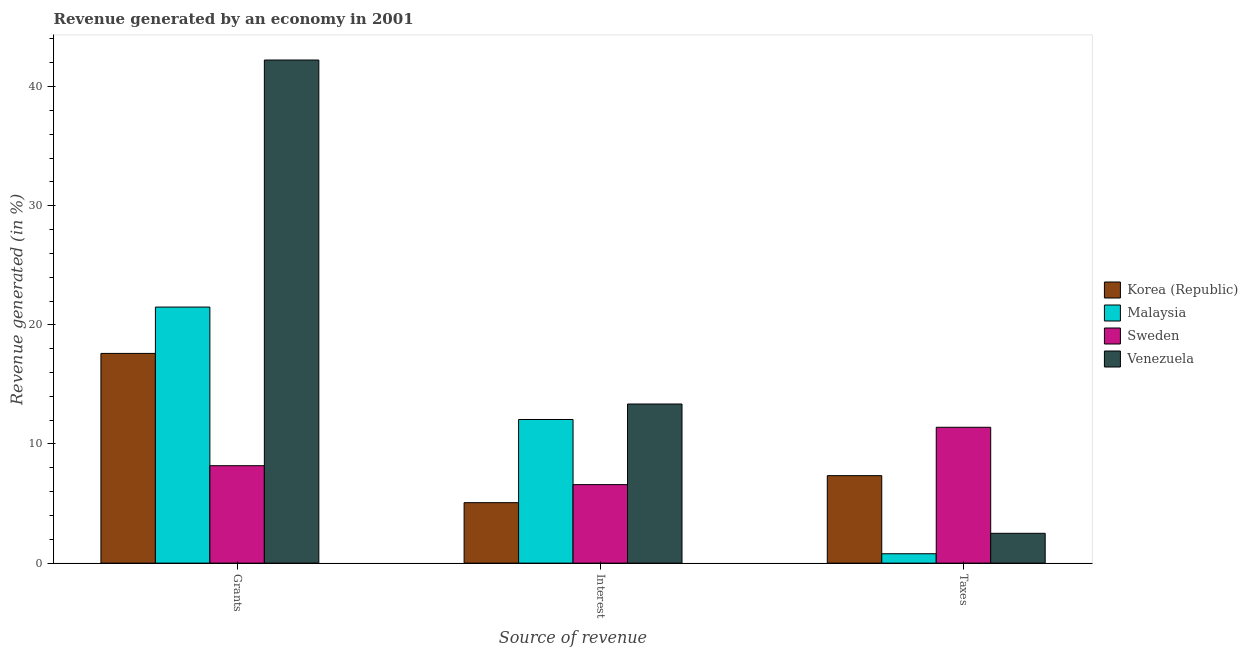Are the number of bars on each tick of the X-axis equal?
Offer a very short reply. Yes. How many bars are there on the 3rd tick from the right?
Give a very brief answer. 4. What is the label of the 1st group of bars from the left?
Provide a short and direct response. Grants. What is the percentage of revenue generated by taxes in Korea (Republic)?
Ensure brevity in your answer.  7.34. Across all countries, what is the maximum percentage of revenue generated by interest?
Provide a short and direct response. 13.35. Across all countries, what is the minimum percentage of revenue generated by interest?
Make the answer very short. 5.07. In which country was the percentage of revenue generated by interest maximum?
Provide a succinct answer. Venezuela. In which country was the percentage of revenue generated by grants minimum?
Offer a very short reply. Sweden. What is the total percentage of revenue generated by grants in the graph?
Give a very brief answer. 89.49. What is the difference between the percentage of revenue generated by interest in Venezuela and that in Malaysia?
Provide a short and direct response. 1.3. What is the difference between the percentage of revenue generated by grants in Korea (Republic) and the percentage of revenue generated by interest in Malaysia?
Provide a short and direct response. 5.55. What is the average percentage of revenue generated by grants per country?
Offer a terse response. 22.37. What is the difference between the percentage of revenue generated by interest and percentage of revenue generated by taxes in Venezuela?
Offer a very short reply. 10.85. What is the ratio of the percentage of revenue generated by taxes in Malaysia to that in Korea (Republic)?
Provide a succinct answer. 0.11. Is the percentage of revenue generated by interest in Malaysia less than that in Sweden?
Your answer should be very brief. No. What is the difference between the highest and the second highest percentage of revenue generated by grants?
Give a very brief answer. 20.73. What is the difference between the highest and the lowest percentage of revenue generated by taxes?
Your answer should be very brief. 10.62. What does the 2nd bar from the right in Taxes represents?
Offer a very short reply. Sweden. Are all the bars in the graph horizontal?
Your response must be concise. No. How many countries are there in the graph?
Give a very brief answer. 4. Are the values on the major ticks of Y-axis written in scientific E-notation?
Ensure brevity in your answer.  No. Does the graph contain any zero values?
Keep it short and to the point. No. Does the graph contain grids?
Provide a short and direct response. No. How many legend labels are there?
Provide a succinct answer. 4. What is the title of the graph?
Offer a terse response. Revenue generated by an economy in 2001. What is the label or title of the X-axis?
Provide a short and direct response. Source of revenue. What is the label or title of the Y-axis?
Offer a terse response. Revenue generated (in %). What is the Revenue generated (in %) of Korea (Republic) in Grants?
Keep it short and to the point. 17.6. What is the Revenue generated (in %) in Malaysia in Grants?
Ensure brevity in your answer.  21.49. What is the Revenue generated (in %) in Sweden in Grants?
Your response must be concise. 8.18. What is the Revenue generated (in %) in Venezuela in Grants?
Your response must be concise. 42.23. What is the Revenue generated (in %) of Korea (Republic) in Interest?
Offer a terse response. 5.07. What is the Revenue generated (in %) of Malaysia in Interest?
Keep it short and to the point. 12.06. What is the Revenue generated (in %) in Sweden in Interest?
Offer a terse response. 6.59. What is the Revenue generated (in %) in Venezuela in Interest?
Give a very brief answer. 13.35. What is the Revenue generated (in %) of Korea (Republic) in Taxes?
Offer a very short reply. 7.34. What is the Revenue generated (in %) of Malaysia in Taxes?
Your response must be concise. 0.79. What is the Revenue generated (in %) of Sweden in Taxes?
Your answer should be compact. 11.4. What is the Revenue generated (in %) of Venezuela in Taxes?
Offer a very short reply. 2.5. Across all Source of revenue, what is the maximum Revenue generated (in %) in Korea (Republic)?
Offer a terse response. 17.6. Across all Source of revenue, what is the maximum Revenue generated (in %) in Malaysia?
Provide a short and direct response. 21.49. Across all Source of revenue, what is the maximum Revenue generated (in %) in Sweden?
Ensure brevity in your answer.  11.4. Across all Source of revenue, what is the maximum Revenue generated (in %) in Venezuela?
Give a very brief answer. 42.23. Across all Source of revenue, what is the minimum Revenue generated (in %) of Korea (Republic)?
Your answer should be compact. 5.07. Across all Source of revenue, what is the minimum Revenue generated (in %) of Malaysia?
Ensure brevity in your answer.  0.79. Across all Source of revenue, what is the minimum Revenue generated (in %) in Sweden?
Your answer should be very brief. 6.59. Across all Source of revenue, what is the minimum Revenue generated (in %) in Venezuela?
Make the answer very short. 2.5. What is the total Revenue generated (in %) of Korea (Republic) in the graph?
Offer a very short reply. 30.02. What is the total Revenue generated (in %) in Malaysia in the graph?
Your answer should be very brief. 34.33. What is the total Revenue generated (in %) of Sweden in the graph?
Your answer should be very brief. 26.16. What is the total Revenue generated (in %) of Venezuela in the graph?
Offer a terse response. 58.08. What is the difference between the Revenue generated (in %) in Korea (Republic) in Grants and that in Interest?
Your response must be concise. 12.53. What is the difference between the Revenue generated (in %) of Malaysia in Grants and that in Interest?
Give a very brief answer. 9.44. What is the difference between the Revenue generated (in %) in Sweden in Grants and that in Interest?
Ensure brevity in your answer.  1.59. What is the difference between the Revenue generated (in %) in Venezuela in Grants and that in Interest?
Give a very brief answer. 28.87. What is the difference between the Revenue generated (in %) in Korea (Republic) in Grants and that in Taxes?
Provide a short and direct response. 10.26. What is the difference between the Revenue generated (in %) in Malaysia in Grants and that in Taxes?
Your answer should be very brief. 20.7. What is the difference between the Revenue generated (in %) of Sweden in Grants and that in Taxes?
Give a very brief answer. -3.23. What is the difference between the Revenue generated (in %) of Venezuela in Grants and that in Taxes?
Your response must be concise. 39.72. What is the difference between the Revenue generated (in %) of Korea (Republic) in Interest and that in Taxes?
Give a very brief answer. -2.27. What is the difference between the Revenue generated (in %) in Malaysia in Interest and that in Taxes?
Your response must be concise. 11.27. What is the difference between the Revenue generated (in %) of Sweden in Interest and that in Taxes?
Make the answer very short. -4.82. What is the difference between the Revenue generated (in %) in Venezuela in Interest and that in Taxes?
Your answer should be very brief. 10.85. What is the difference between the Revenue generated (in %) of Korea (Republic) in Grants and the Revenue generated (in %) of Malaysia in Interest?
Ensure brevity in your answer.  5.55. What is the difference between the Revenue generated (in %) of Korea (Republic) in Grants and the Revenue generated (in %) of Sweden in Interest?
Your response must be concise. 11.01. What is the difference between the Revenue generated (in %) in Korea (Republic) in Grants and the Revenue generated (in %) in Venezuela in Interest?
Provide a short and direct response. 4.25. What is the difference between the Revenue generated (in %) of Malaysia in Grants and the Revenue generated (in %) of Sweden in Interest?
Ensure brevity in your answer.  14.9. What is the difference between the Revenue generated (in %) of Malaysia in Grants and the Revenue generated (in %) of Venezuela in Interest?
Offer a terse response. 8.14. What is the difference between the Revenue generated (in %) in Sweden in Grants and the Revenue generated (in %) in Venezuela in Interest?
Offer a terse response. -5.18. What is the difference between the Revenue generated (in %) of Korea (Republic) in Grants and the Revenue generated (in %) of Malaysia in Taxes?
Ensure brevity in your answer.  16.81. What is the difference between the Revenue generated (in %) of Korea (Republic) in Grants and the Revenue generated (in %) of Sweden in Taxes?
Provide a short and direct response. 6.2. What is the difference between the Revenue generated (in %) in Korea (Republic) in Grants and the Revenue generated (in %) in Venezuela in Taxes?
Your response must be concise. 15.1. What is the difference between the Revenue generated (in %) in Malaysia in Grants and the Revenue generated (in %) in Sweden in Taxes?
Your answer should be compact. 10.09. What is the difference between the Revenue generated (in %) of Malaysia in Grants and the Revenue generated (in %) of Venezuela in Taxes?
Keep it short and to the point. 18.99. What is the difference between the Revenue generated (in %) in Sweden in Grants and the Revenue generated (in %) in Venezuela in Taxes?
Provide a short and direct response. 5.67. What is the difference between the Revenue generated (in %) in Korea (Republic) in Interest and the Revenue generated (in %) in Malaysia in Taxes?
Make the answer very short. 4.29. What is the difference between the Revenue generated (in %) of Korea (Republic) in Interest and the Revenue generated (in %) of Sweden in Taxes?
Offer a terse response. -6.33. What is the difference between the Revenue generated (in %) in Korea (Republic) in Interest and the Revenue generated (in %) in Venezuela in Taxes?
Provide a short and direct response. 2.57. What is the difference between the Revenue generated (in %) of Malaysia in Interest and the Revenue generated (in %) of Sweden in Taxes?
Provide a short and direct response. 0.65. What is the difference between the Revenue generated (in %) in Malaysia in Interest and the Revenue generated (in %) in Venezuela in Taxes?
Keep it short and to the point. 9.55. What is the difference between the Revenue generated (in %) in Sweden in Interest and the Revenue generated (in %) in Venezuela in Taxes?
Your answer should be very brief. 4.08. What is the average Revenue generated (in %) of Korea (Republic) per Source of revenue?
Your answer should be compact. 10.01. What is the average Revenue generated (in %) in Malaysia per Source of revenue?
Offer a very short reply. 11.44. What is the average Revenue generated (in %) in Sweden per Source of revenue?
Offer a terse response. 8.72. What is the average Revenue generated (in %) in Venezuela per Source of revenue?
Your answer should be compact. 19.36. What is the difference between the Revenue generated (in %) in Korea (Republic) and Revenue generated (in %) in Malaysia in Grants?
Offer a terse response. -3.89. What is the difference between the Revenue generated (in %) in Korea (Republic) and Revenue generated (in %) in Sweden in Grants?
Ensure brevity in your answer.  9.42. What is the difference between the Revenue generated (in %) of Korea (Republic) and Revenue generated (in %) of Venezuela in Grants?
Offer a terse response. -24.62. What is the difference between the Revenue generated (in %) in Malaysia and Revenue generated (in %) in Sweden in Grants?
Your response must be concise. 13.31. What is the difference between the Revenue generated (in %) of Malaysia and Revenue generated (in %) of Venezuela in Grants?
Your response must be concise. -20.73. What is the difference between the Revenue generated (in %) in Sweden and Revenue generated (in %) in Venezuela in Grants?
Keep it short and to the point. -34.05. What is the difference between the Revenue generated (in %) of Korea (Republic) and Revenue generated (in %) of Malaysia in Interest?
Ensure brevity in your answer.  -6.98. What is the difference between the Revenue generated (in %) in Korea (Republic) and Revenue generated (in %) in Sweden in Interest?
Your response must be concise. -1.51. What is the difference between the Revenue generated (in %) in Korea (Republic) and Revenue generated (in %) in Venezuela in Interest?
Offer a terse response. -8.28. What is the difference between the Revenue generated (in %) in Malaysia and Revenue generated (in %) in Sweden in Interest?
Offer a terse response. 5.47. What is the difference between the Revenue generated (in %) of Malaysia and Revenue generated (in %) of Venezuela in Interest?
Ensure brevity in your answer.  -1.3. What is the difference between the Revenue generated (in %) in Sweden and Revenue generated (in %) in Venezuela in Interest?
Keep it short and to the point. -6.77. What is the difference between the Revenue generated (in %) of Korea (Republic) and Revenue generated (in %) of Malaysia in Taxes?
Keep it short and to the point. 6.55. What is the difference between the Revenue generated (in %) in Korea (Republic) and Revenue generated (in %) in Sweden in Taxes?
Your response must be concise. -4.06. What is the difference between the Revenue generated (in %) of Korea (Republic) and Revenue generated (in %) of Venezuela in Taxes?
Your answer should be compact. 4.84. What is the difference between the Revenue generated (in %) of Malaysia and Revenue generated (in %) of Sweden in Taxes?
Your answer should be very brief. -10.62. What is the difference between the Revenue generated (in %) in Malaysia and Revenue generated (in %) in Venezuela in Taxes?
Offer a very short reply. -1.72. What is the difference between the Revenue generated (in %) in Sweden and Revenue generated (in %) in Venezuela in Taxes?
Ensure brevity in your answer.  8.9. What is the ratio of the Revenue generated (in %) in Korea (Republic) in Grants to that in Interest?
Your answer should be very brief. 3.47. What is the ratio of the Revenue generated (in %) of Malaysia in Grants to that in Interest?
Your answer should be compact. 1.78. What is the ratio of the Revenue generated (in %) of Sweden in Grants to that in Interest?
Your answer should be very brief. 1.24. What is the ratio of the Revenue generated (in %) of Venezuela in Grants to that in Interest?
Give a very brief answer. 3.16. What is the ratio of the Revenue generated (in %) of Korea (Republic) in Grants to that in Taxes?
Provide a succinct answer. 2.4. What is the ratio of the Revenue generated (in %) of Malaysia in Grants to that in Taxes?
Ensure brevity in your answer.  27.33. What is the ratio of the Revenue generated (in %) of Sweden in Grants to that in Taxes?
Ensure brevity in your answer.  0.72. What is the ratio of the Revenue generated (in %) in Venezuela in Grants to that in Taxes?
Keep it short and to the point. 16.88. What is the ratio of the Revenue generated (in %) of Korea (Republic) in Interest to that in Taxes?
Provide a short and direct response. 0.69. What is the ratio of the Revenue generated (in %) of Malaysia in Interest to that in Taxes?
Give a very brief answer. 15.33. What is the ratio of the Revenue generated (in %) in Sweden in Interest to that in Taxes?
Provide a succinct answer. 0.58. What is the ratio of the Revenue generated (in %) of Venezuela in Interest to that in Taxes?
Offer a very short reply. 5.34. What is the difference between the highest and the second highest Revenue generated (in %) in Korea (Republic)?
Your answer should be very brief. 10.26. What is the difference between the highest and the second highest Revenue generated (in %) of Malaysia?
Provide a succinct answer. 9.44. What is the difference between the highest and the second highest Revenue generated (in %) of Sweden?
Ensure brevity in your answer.  3.23. What is the difference between the highest and the second highest Revenue generated (in %) of Venezuela?
Make the answer very short. 28.87. What is the difference between the highest and the lowest Revenue generated (in %) in Korea (Republic)?
Your answer should be compact. 12.53. What is the difference between the highest and the lowest Revenue generated (in %) of Malaysia?
Your response must be concise. 20.7. What is the difference between the highest and the lowest Revenue generated (in %) in Sweden?
Provide a short and direct response. 4.82. What is the difference between the highest and the lowest Revenue generated (in %) of Venezuela?
Ensure brevity in your answer.  39.72. 